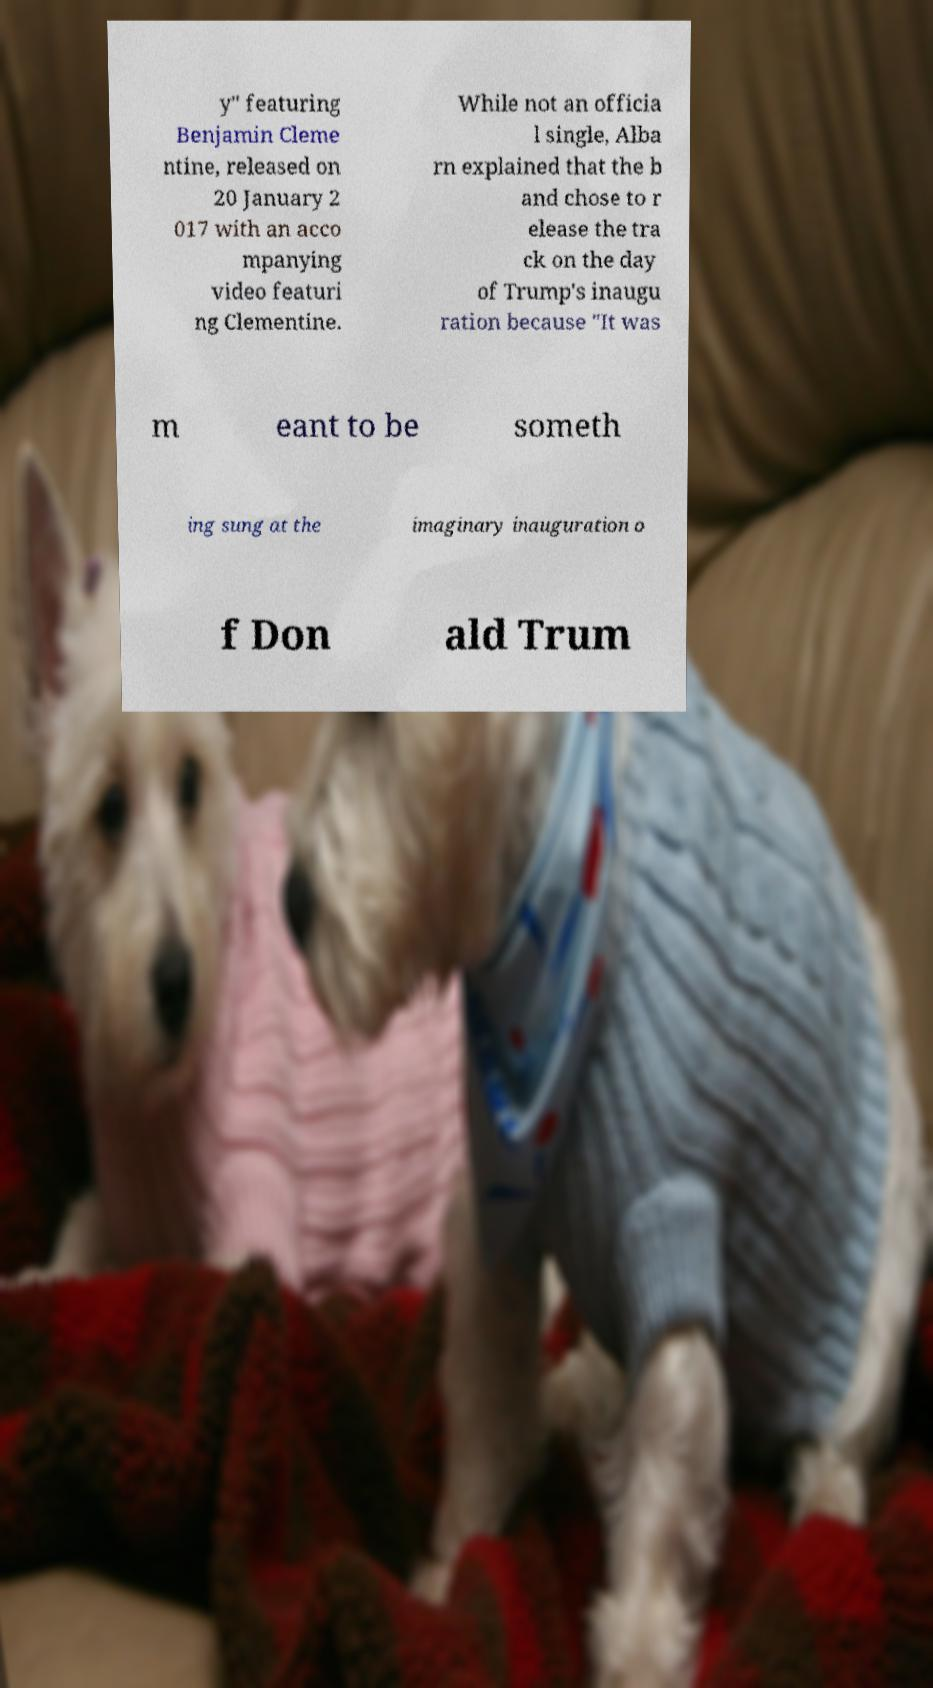There's text embedded in this image that I need extracted. Can you transcribe it verbatim? y" featuring Benjamin Cleme ntine, released on 20 January 2 017 with an acco mpanying video featuri ng Clementine. While not an officia l single, Alba rn explained that the b and chose to r elease the tra ck on the day of Trump's inaugu ration because "It was m eant to be someth ing sung at the imaginary inauguration o f Don ald Trum 